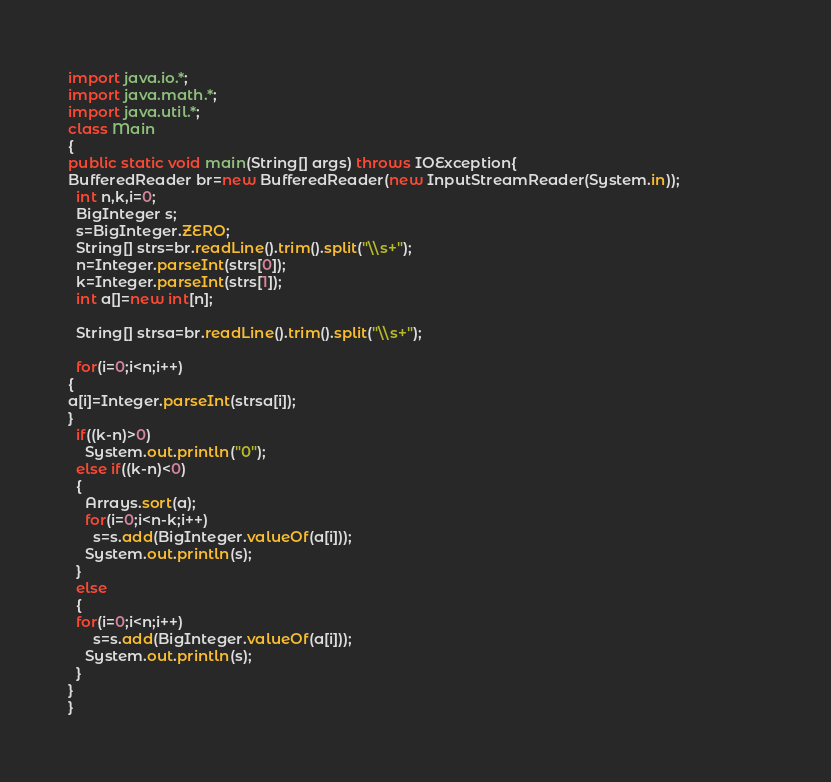<code> <loc_0><loc_0><loc_500><loc_500><_Java_>import java.io.*;
import java.math.*;
import java.util.*;
class Main
{
public static void main(String[] args) throws IOException{
BufferedReader br=new BufferedReader(new InputStreamReader(System.in));			        
  int n,k,i=0;
  BigInteger s;
  s=BigInteger.ZERO;
  String[] strs=br.readLine().trim().split("\\s+");
  n=Integer.parseInt(strs[0]);
  k=Integer.parseInt(strs[1]);
  int a[]=new int[n];

  String[] strsa=br.readLine().trim().split("\\s+");
  
  for(i=0;i<n;i++)                 
{                                              
a[i]=Integer.parseInt(strsa[i]);
}
  if((k-n)>0)
    System.out.println("0");
  else if((k-n)<0)
  {
    Arrays.sort(a);
    for(i=0;i<n-k;i++)
      s=s.add(BigInteger.valueOf(a[i]));
    System.out.println(s);
  }
  else
  {
  for(i=0;i<n;i++)
      s=s.add(BigInteger.valueOf(a[i]));
    System.out.println(s);
  }
}
}
</code> 